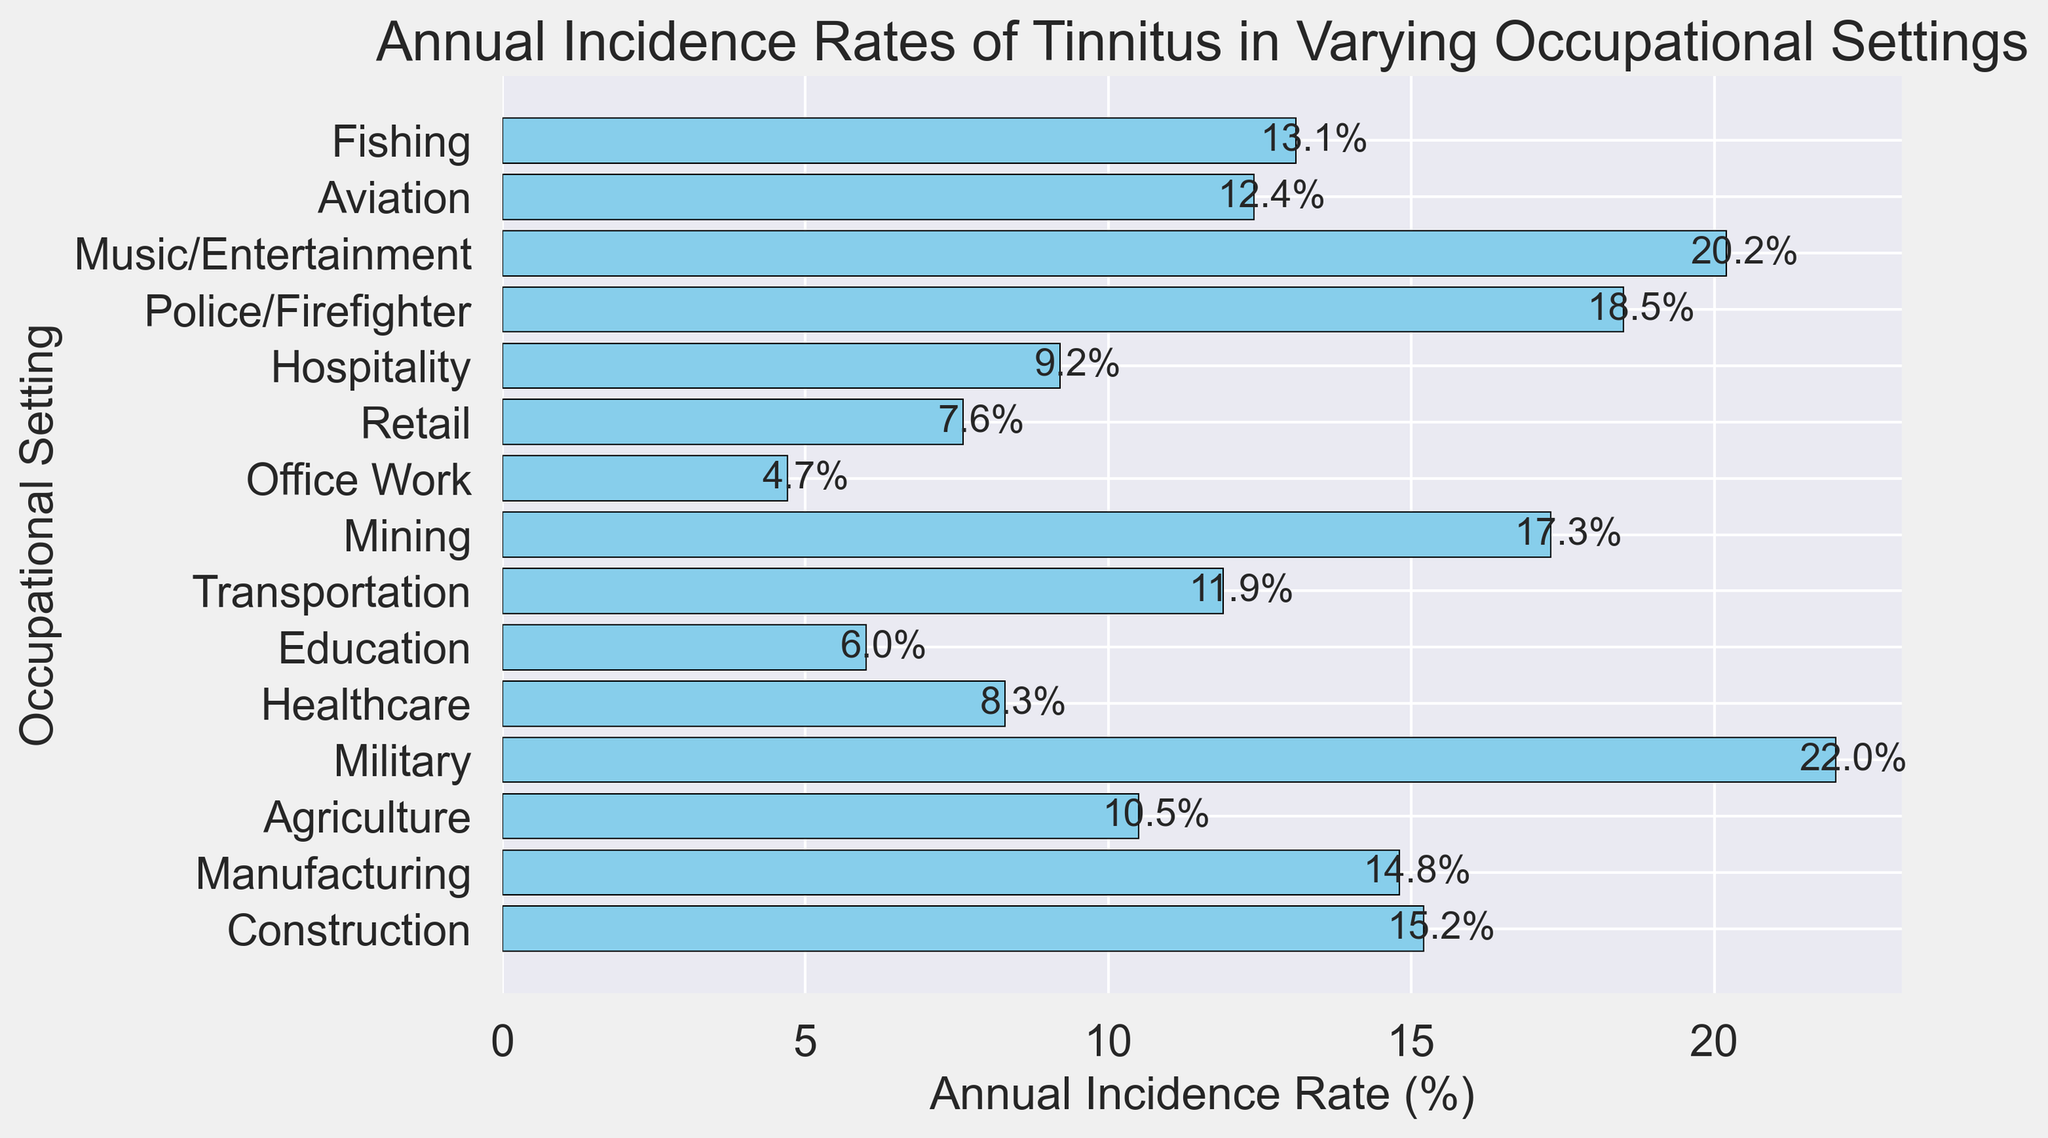Which occupational setting has the highest annual incidence rate of tinnitus? By looking at the figure, identify the bar that extends the farthest to the right. The Military setting has the longest bar, indicating the highest incidence rate.
Answer: Military Which occupational setting has the lowest annual incidence rate? By examining the bars in the figure, the shortest bar represents the lowest incidence rate. Office Work has the shortest bar.
Answer: Office Work What is the difference in the annual incidence rates of tinnitus between the Military and Office Work occupational settings? The figure shows the Military with a rate of 22.0% and Office Work with 4.7%. Subtract 4.7% from 22.0% to find the difference: 22.0% - 4.7% = 17.3%.
Answer: 17.3% Which occupational settings have an annual incidence rate of tinnitus greater than 15%? Identify all bars that extend beyond the 15% mark on the x-axis. These settings are: Construction (15.2%), Military (22.0%), Mining (17.3%), Police/Firefighter (18.5%), and Music/Entertainment (20.2%).
Answer: Construction, Military, Mining, Police/Firefighter, Music/Entertainment What is the average annual incidence rate of tinnitus across all occupational settings? Sum all the incidence rates and divide by the number of occupational settings. The sum of rates is 15.2 + 14.8 + 10.5 + 22.0 + 8.3 + 6.0 + 11.9 + 17.3 + 4.7 + 7.6 + 9.2 + 18.5 + 20.2 + 12.4 + 13.1 = 192.7%. There are 15 settings, so the average rate is 192.7% / 15 = 12.85%.
Answer: 12.85% What is the sum of the annual incidence rates of tinnitus for Construction, Manufacturing, and Mining? Identify the rates for Construction (15.2%), Manufacturing (14.8%), and Mining (17.3%). Sum these rates: 15.2% + 14.8% + 17.3% = 47.3%.
Answer: 47.3% Which occupational setting is closest to the average annual incidence rate of tinnitus? The average rate is 12.85%. Compare the rates of all settings to find the closest one: Agriculture (10.5%), Transportation (11.9%), Music/Entertainment (20.2%), and Aviation (12.4%). The closest rate is Aviation at 12.4%.
Answer: Aviation What is the total number of occupational settings with annual incidence rates between 10% and 20% inclusive? Count the bars whose rates fall between this range: Construction (15.2%), Manufacturing (14.8%), Agriculture (10.5%), Transportation (11.9%), Mining (17.3%), Police/Firefighter (18.5%), Music/Entertainment (20.2%), and Aviation (12.4%). There are 8 such settings.
Answer: 8 How much higher is the annual incidence rate of tinnitus in the Military compared to Education? The Military has a rate of 22.0% and Education has a rate of 6.0%. Subtract the rate of Education from Military: 22.0% - 6.0% = 16.0%.
Answer: 16.0% What is the median annual incidence rate of tinnitus across the listed occupational settings? List the rates in ascending order: 4.7, 6.0, 7.6, 8.3, 9.2, 10.5, 11.9, 12.4, 13.1, 14.8, 15.2, 17.3, 18.5, 20.2, 22.0. With 15 values, the median is the 8th value: 12.4%.
Answer: 12.4% 